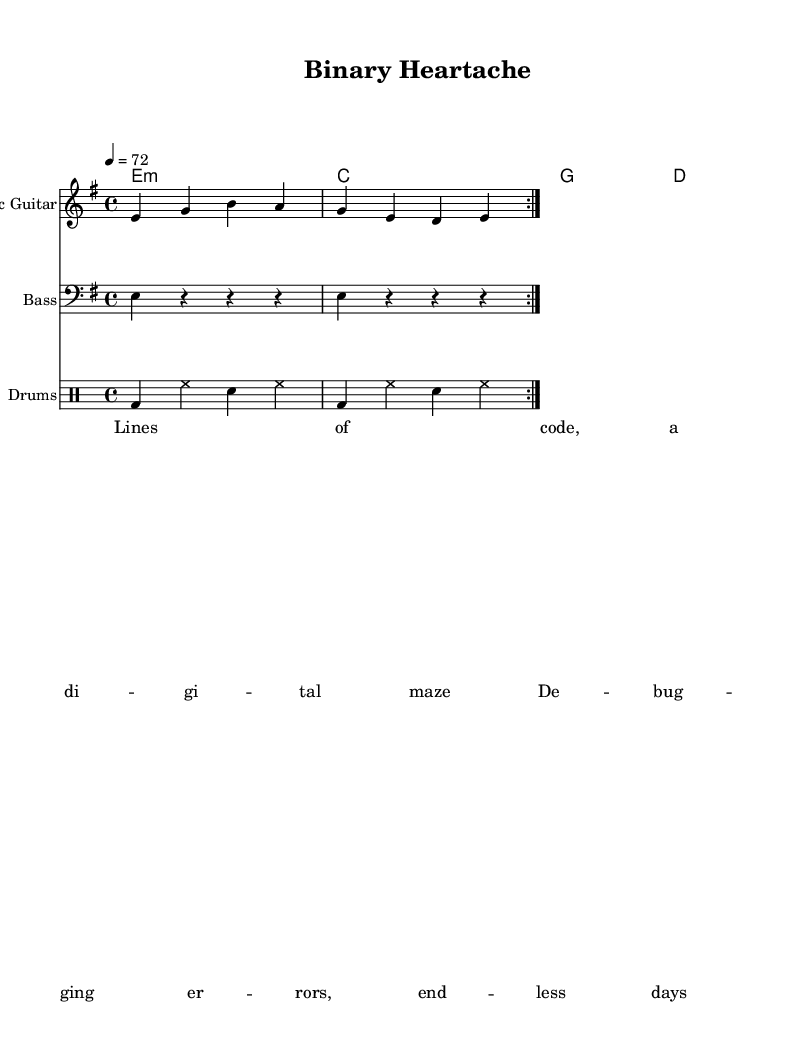What is the key signature of this piece? The key signature is E minor, which is indicated by one sharp on the staff (F#).
Answer: E minor What is the time signature of this music? The time signature is 4/4, which is noted at the beginning of the score, indicating four beats per measure.
Answer: 4/4 What is the tempo marking? The tempo marking indicates a speed of 72 beats per minute, printed at the beginning of the score as "4 = 72".
Answer: 72 How many measures are repeated in the electric guitar part? The electric guitar part contains a repeated section that is marked with "volta 2", indicating it should be played twice.
Answer: 2 What type of chord is played in the first measure? The first measure contains an E minor chord, which is indicated in the chords part with "e1:m".
Answer: E minor What is the main theme depicted in the lyrics? The lyrics discuss struggles with coding and debugging, highlighting the challenges faced by computer scientists.
Answer: Coding struggles How is the music structured? The music features a standard verse format, as seen with the lyrics section aligned under the melody, indicating it follows a typical song structure.
Answer: Verse format 